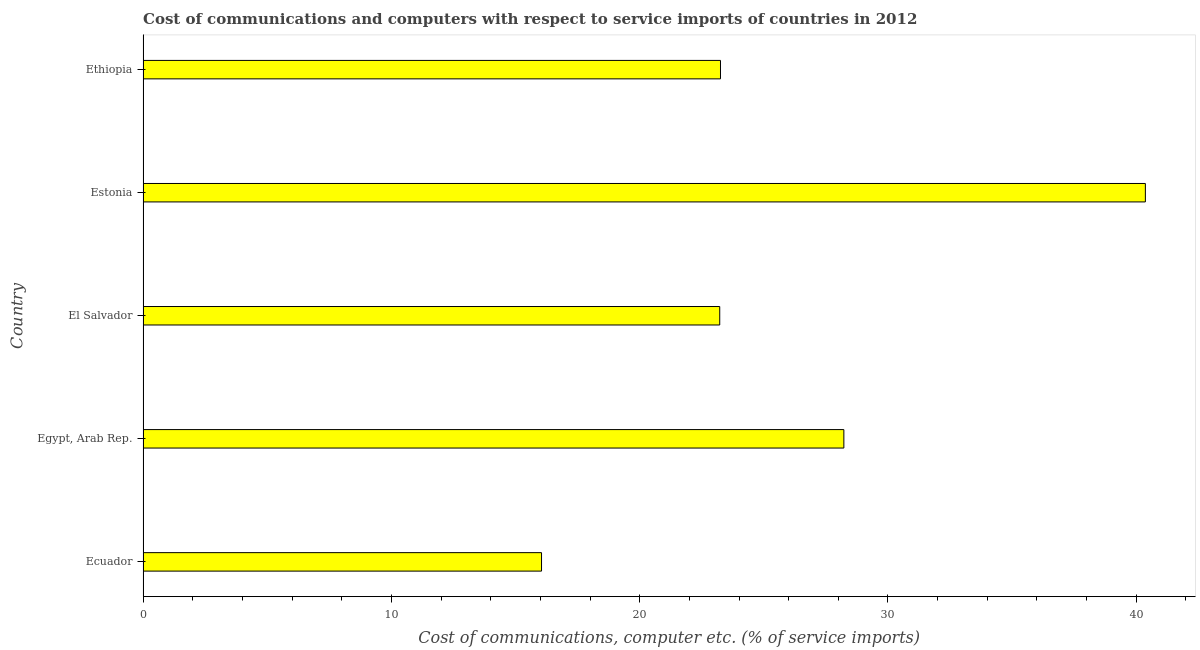Does the graph contain grids?
Keep it short and to the point. No. What is the title of the graph?
Ensure brevity in your answer.  Cost of communications and computers with respect to service imports of countries in 2012. What is the label or title of the X-axis?
Your answer should be very brief. Cost of communications, computer etc. (% of service imports). What is the label or title of the Y-axis?
Offer a very short reply. Country. What is the cost of communications and computer in Ethiopia?
Your answer should be compact. 23.25. Across all countries, what is the maximum cost of communications and computer?
Keep it short and to the point. 40.37. Across all countries, what is the minimum cost of communications and computer?
Ensure brevity in your answer.  16.05. In which country was the cost of communications and computer maximum?
Ensure brevity in your answer.  Estonia. In which country was the cost of communications and computer minimum?
Give a very brief answer. Ecuador. What is the sum of the cost of communications and computer?
Keep it short and to the point. 131.11. What is the difference between the cost of communications and computer in El Salvador and Ethiopia?
Keep it short and to the point. -0.03. What is the average cost of communications and computer per country?
Ensure brevity in your answer.  26.22. What is the median cost of communications and computer?
Offer a very short reply. 23.25. In how many countries, is the cost of communications and computer greater than 32 %?
Provide a succinct answer. 1. What is the ratio of the cost of communications and computer in Egypt, Arab Rep. to that in El Salvador?
Your answer should be very brief. 1.22. Is the cost of communications and computer in Ecuador less than that in Estonia?
Your response must be concise. Yes. Is the difference between the cost of communications and computer in Ecuador and El Salvador greater than the difference between any two countries?
Your response must be concise. No. What is the difference between the highest and the second highest cost of communications and computer?
Offer a very short reply. 12.14. What is the difference between the highest and the lowest cost of communications and computer?
Give a very brief answer. 24.32. How many countries are there in the graph?
Your response must be concise. 5. What is the Cost of communications, computer etc. (% of service imports) in Ecuador?
Make the answer very short. 16.05. What is the Cost of communications, computer etc. (% of service imports) of Egypt, Arab Rep.?
Your answer should be very brief. 28.22. What is the Cost of communications, computer etc. (% of service imports) of El Salvador?
Your answer should be very brief. 23.22. What is the Cost of communications, computer etc. (% of service imports) of Estonia?
Offer a terse response. 40.37. What is the Cost of communications, computer etc. (% of service imports) of Ethiopia?
Give a very brief answer. 23.25. What is the difference between the Cost of communications, computer etc. (% of service imports) in Ecuador and Egypt, Arab Rep.?
Keep it short and to the point. -12.18. What is the difference between the Cost of communications, computer etc. (% of service imports) in Ecuador and El Salvador?
Provide a short and direct response. -7.18. What is the difference between the Cost of communications, computer etc. (% of service imports) in Ecuador and Estonia?
Your response must be concise. -24.32. What is the difference between the Cost of communications, computer etc. (% of service imports) in Ecuador and Ethiopia?
Provide a succinct answer. -7.21. What is the difference between the Cost of communications, computer etc. (% of service imports) in Egypt, Arab Rep. and El Salvador?
Keep it short and to the point. 5. What is the difference between the Cost of communications, computer etc. (% of service imports) in Egypt, Arab Rep. and Estonia?
Provide a succinct answer. -12.14. What is the difference between the Cost of communications, computer etc. (% of service imports) in Egypt, Arab Rep. and Ethiopia?
Ensure brevity in your answer.  4.97. What is the difference between the Cost of communications, computer etc. (% of service imports) in El Salvador and Estonia?
Your answer should be very brief. -17.14. What is the difference between the Cost of communications, computer etc. (% of service imports) in El Salvador and Ethiopia?
Provide a short and direct response. -0.03. What is the difference between the Cost of communications, computer etc. (% of service imports) in Estonia and Ethiopia?
Your response must be concise. 17.11. What is the ratio of the Cost of communications, computer etc. (% of service imports) in Ecuador to that in Egypt, Arab Rep.?
Your answer should be compact. 0.57. What is the ratio of the Cost of communications, computer etc. (% of service imports) in Ecuador to that in El Salvador?
Keep it short and to the point. 0.69. What is the ratio of the Cost of communications, computer etc. (% of service imports) in Ecuador to that in Estonia?
Provide a succinct answer. 0.4. What is the ratio of the Cost of communications, computer etc. (% of service imports) in Ecuador to that in Ethiopia?
Provide a short and direct response. 0.69. What is the ratio of the Cost of communications, computer etc. (% of service imports) in Egypt, Arab Rep. to that in El Salvador?
Keep it short and to the point. 1.22. What is the ratio of the Cost of communications, computer etc. (% of service imports) in Egypt, Arab Rep. to that in Estonia?
Offer a very short reply. 0.7. What is the ratio of the Cost of communications, computer etc. (% of service imports) in Egypt, Arab Rep. to that in Ethiopia?
Your answer should be compact. 1.21. What is the ratio of the Cost of communications, computer etc. (% of service imports) in El Salvador to that in Estonia?
Your answer should be very brief. 0.57. What is the ratio of the Cost of communications, computer etc. (% of service imports) in El Salvador to that in Ethiopia?
Your response must be concise. 1. What is the ratio of the Cost of communications, computer etc. (% of service imports) in Estonia to that in Ethiopia?
Your response must be concise. 1.74. 